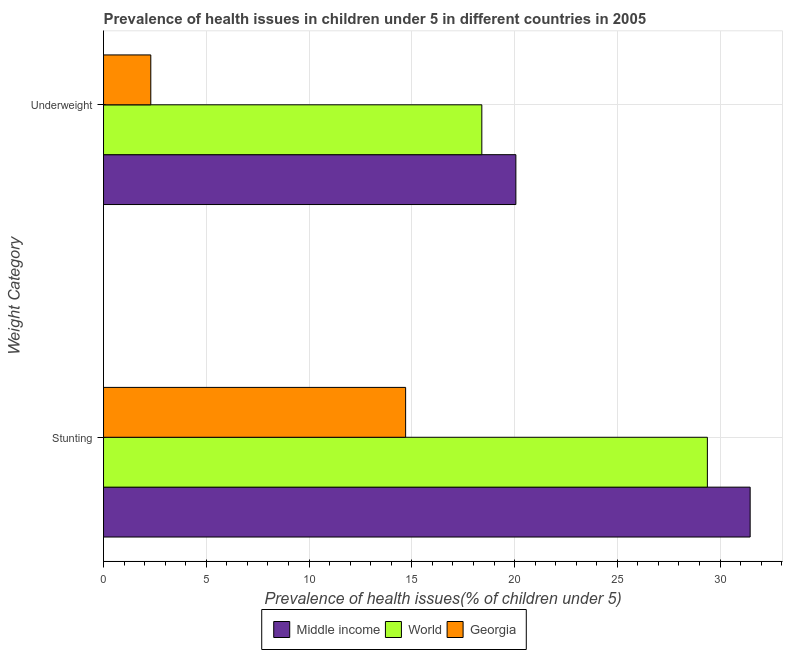How many bars are there on the 1st tick from the top?
Ensure brevity in your answer.  3. What is the label of the 1st group of bars from the top?
Ensure brevity in your answer.  Underweight. What is the percentage of underweight children in Georgia?
Your answer should be very brief. 2.3. Across all countries, what is the maximum percentage of stunted children?
Your answer should be compact. 31.46. Across all countries, what is the minimum percentage of underweight children?
Your answer should be very brief. 2.3. In which country was the percentage of underweight children maximum?
Your answer should be compact. Middle income. In which country was the percentage of stunted children minimum?
Your answer should be compact. Georgia. What is the total percentage of stunted children in the graph?
Provide a short and direct response. 75.55. What is the difference between the percentage of stunted children in World and that in Middle income?
Provide a short and direct response. -2.08. What is the difference between the percentage of stunted children in World and the percentage of underweight children in Middle income?
Keep it short and to the point. 9.32. What is the average percentage of underweight children per country?
Offer a terse response. 13.59. What is the difference between the percentage of stunted children and percentage of underweight children in Middle income?
Keep it short and to the point. 11.4. What is the ratio of the percentage of underweight children in Middle income to that in World?
Your response must be concise. 1.09. What does the 2nd bar from the top in Underweight represents?
Make the answer very short. World. Does the graph contain any zero values?
Ensure brevity in your answer.  No. Does the graph contain grids?
Keep it short and to the point. Yes. How many legend labels are there?
Offer a very short reply. 3. What is the title of the graph?
Provide a short and direct response. Prevalence of health issues in children under 5 in different countries in 2005. Does "Puerto Rico" appear as one of the legend labels in the graph?
Give a very brief answer. No. What is the label or title of the X-axis?
Give a very brief answer. Prevalence of health issues(% of children under 5). What is the label or title of the Y-axis?
Ensure brevity in your answer.  Weight Category. What is the Prevalence of health issues(% of children under 5) of Middle income in Stunting?
Provide a short and direct response. 31.46. What is the Prevalence of health issues(% of children under 5) of World in Stunting?
Offer a terse response. 29.38. What is the Prevalence of health issues(% of children under 5) of Georgia in Stunting?
Make the answer very short. 14.7. What is the Prevalence of health issues(% of children under 5) in Middle income in Underweight?
Give a very brief answer. 20.06. What is the Prevalence of health issues(% of children under 5) of World in Underweight?
Keep it short and to the point. 18.41. What is the Prevalence of health issues(% of children under 5) of Georgia in Underweight?
Make the answer very short. 2.3. Across all Weight Category, what is the maximum Prevalence of health issues(% of children under 5) of Middle income?
Provide a short and direct response. 31.46. Across all Weight Category, what is the maximum Prevalence of health issues(% of children under 5) of World?
Make the answer very short. 29.38. Across all Weight Category, what is the maximum Prevalence of health issues(% of children under 5) in Georgia?
Provide a short and direct response. 14.7. Across all Weight Category, what is the minimum Prevalence of health issues(% of children under 5) in Middle income?
Your response must be concise. 20.06. Across all Weight Category, what is the minimum Prevalence of health issues(% of children under 5) in World?
Make the answer very short. 18.41. Across all Weight Category, what is the minimum Prevalence of health issues(% of children under 5) in Georgia?
Provide a succinct answer. 2.3. What is the total Prevalence of health issues(% of children under 5) of Middle income in the graph?
Ensure brevity in your answer.  51.53. What is the total Prevalence of health issues(% of children under 5) of World in the graph?
Offer a very short reply. 47.79. What is the difference between the Prevalence of health issues(% of children under 5) in Middle income in Stunting and that in Underweight?
Ensure brevity in your answer.  11.4. What is the difference between the Prevalence of health issues(% of children under 5) in World in Stunting and that in Underweight?
Make the answer very short. 10.97. What is the difference between the Prevalence of health issues(% of children under 5) in Middle income in Stunting and the Prevalence of health issues(% of children under 5) in World in Underweight?
Offer a very short reply. 13.06. What is the difference between the Prevalence of health issues(% of children under 5) in Middle income in Stunting and the Prevalence of health issues(% of children under 5) in Georgia in Underweight?
Provide a short and direct response. 29.16. What is the difference between the Prevalence of health issues(% of children under 5) in World in Stunting and the Prevalence of health issues(% of children under 5) in Georgia in Underweight?
Keep it short and to the point. 27.08. What is the average Prevalence of health issues(% of children under 5) in Middle income per Weight Category?
Keep it short and to the point. 25.76. What is the average Prevalence of health issues(% of children under 5) in World per Weight Category?
Make the answer very short. 23.9. What is the average Prevalence of health issues(% of children under 5) of Georgia per Weight Category?
Make the answer very short. 8.5. What is the difference between the Prevalence of health issues(% of children under 5) of Middle income and Prevalence of health issues(% of children under 5) of World in Stunting?
Give a very brief answer. 2.08. What is the difference between the Prevalence of health issues(% of children under 5) in Middle income and Prevalence of health issues(% of children under 5) in Georgia in Stunting?
Your answer should be very brief. 16.76. What is the difference between the Prevalence of health issues(% of children under 5) in World and Prevalence of health issues(% of children under 5) in Georgia in Stunting?
Offer a terse response. 14.68. What is the difference between the Prevalence of health issues(% of children under 5) in Middle income and Prevalence of health issues(% of children under 5) in World in Underweight?
Keep it short and to the point. 1.66. What is the difference between the Prevalence of health issues(% of children under 5) of Middle income and Prevalence of health issues(% of children under 5) of Georgia in Underweight?
Your answer should be very brief. 17.76. What is the difference between the Prevalence of health issues(% of children under 5) in World and Prevalence of health issues(% of children under 5) in Georgia in Underweight?
Your answer should be compact. 16.11. What is the ratio of the Prevalence of health issues(% of children under 5) in Middle income in Stunting to that in Underweight?
Give a very brief answer. 1.57. What is the ratio of the Prevalence of health issues(% of children under 5) in World in Stunting to that in Underweight?
Your answer should be compact. 1.6. What is the ratio of the Prevalence of health issues(% of children under 5) in Georgia in Stunting to that in Underweight?
Your answer should be very brief. 6.39. What is the difference between the highest and the second highest Prevalence of health issues(% of children under 5) of Middle income?
Your answer should be very brief. 11.4. What is the difference between the highest and the second highest Prevalence of health issues(% of children under 5) in World?
Provide a succinct answer. 10.97. What is the difference between the highest and the second highest Prevalence of health issues(% of children under 5) in Georgia?
Your response must be concise. 12.4. What is the difference between the highest and the lowest Prevalence of health issues(% of children under 5) in Middle income?
Ensure brevity in your answer.  11.4. What is the difference between the highest and the lowest Prevalence of health issues(% of children under 5) of World?
Your answer should be very brief. 10.97. 